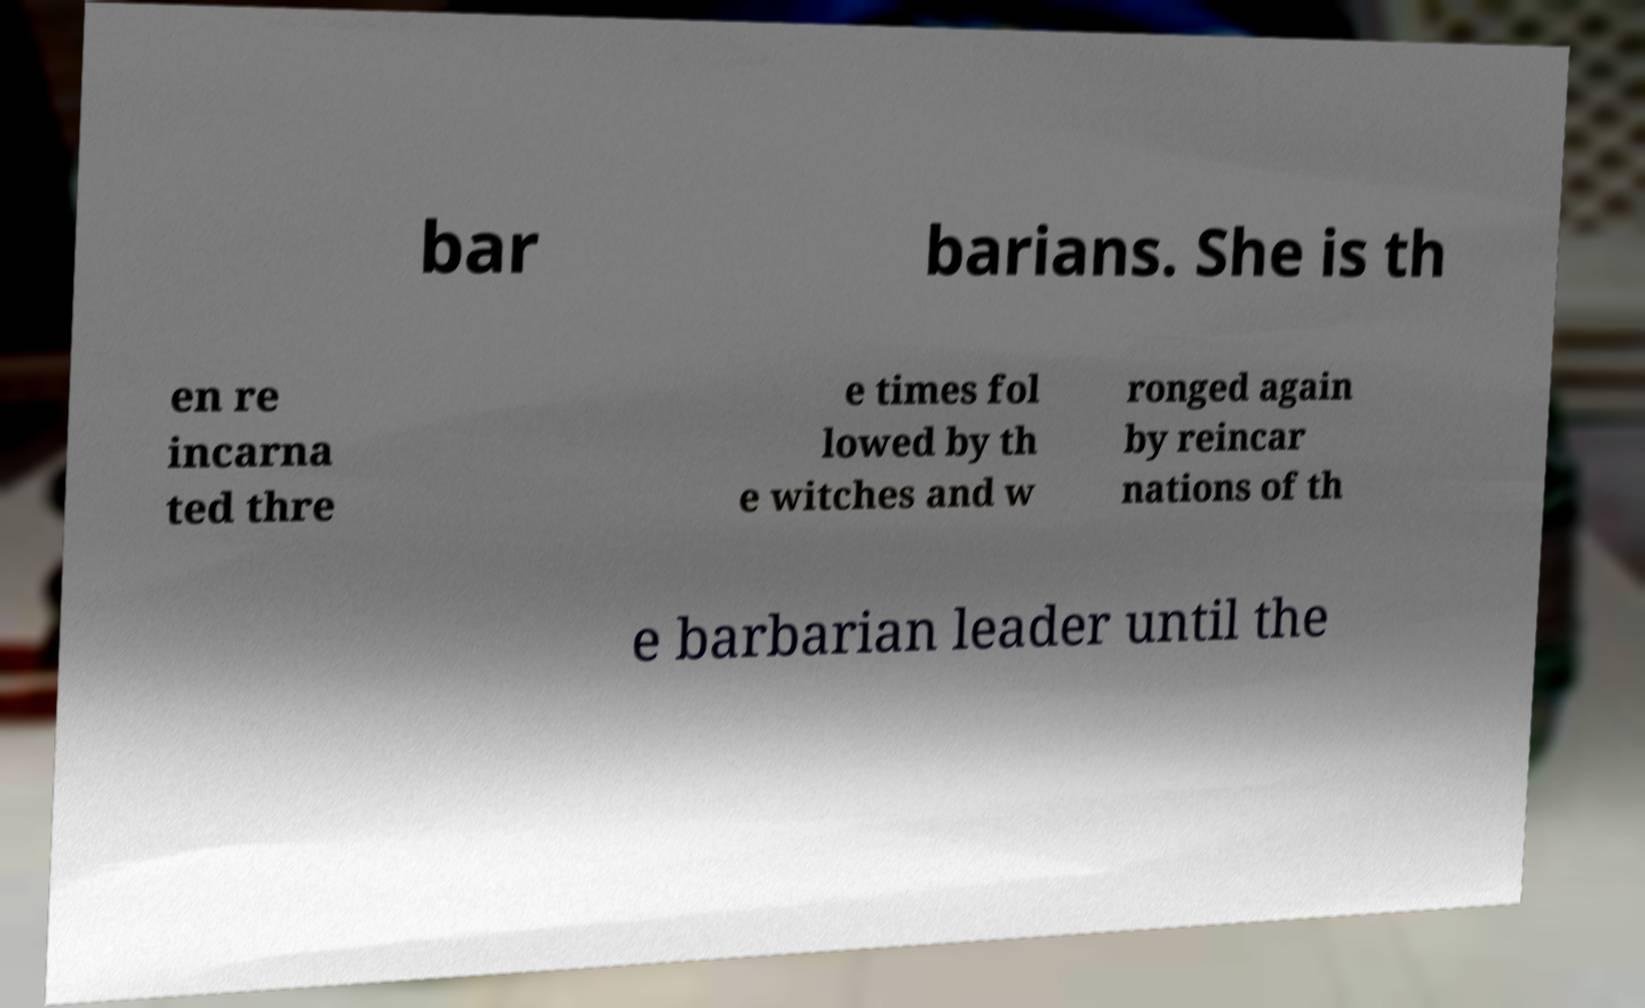Please identify and transcribe the text found in this image. bar barians. She is th en re incarna ted thre e times fol lowed by th e witches and w ronged again by reincar nations of th e barbarian leader until the 